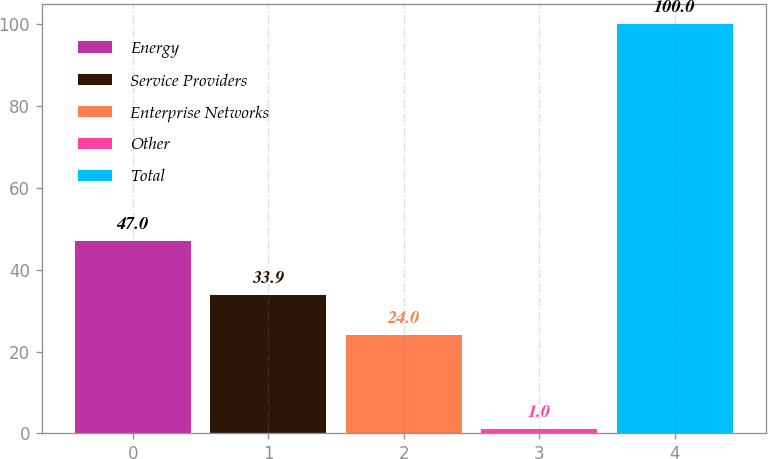Convert chart to OTSL. <chart><loc_0><loc_0><loc_500><loc_500><bar_chart><fcel>Energy<fcel>Service Providers<fcel>Enterprise Networks<fcel>Other<fcel>Total<nl><fcel>47<fcel>33.9<fcel>24<fcel>1<fcel>100<nl></chart> 